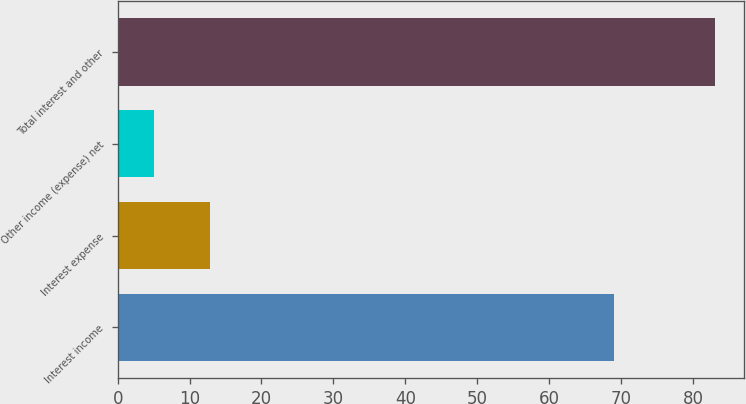<chart> <loc_0><loc_0><loc_500><loc_500><bar_chart><fcel>Interest income<fcel>Interest expense<fcel>Other income (expense) net<fcel>Total interest and other<nl><fcel>69<fcel>12.8<fcel>5<fcel>83<nl></chart> 